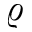Convert formula to latex. <formula><loc_0><loc_0><loc_500><loc_500>\varrho</formula> 